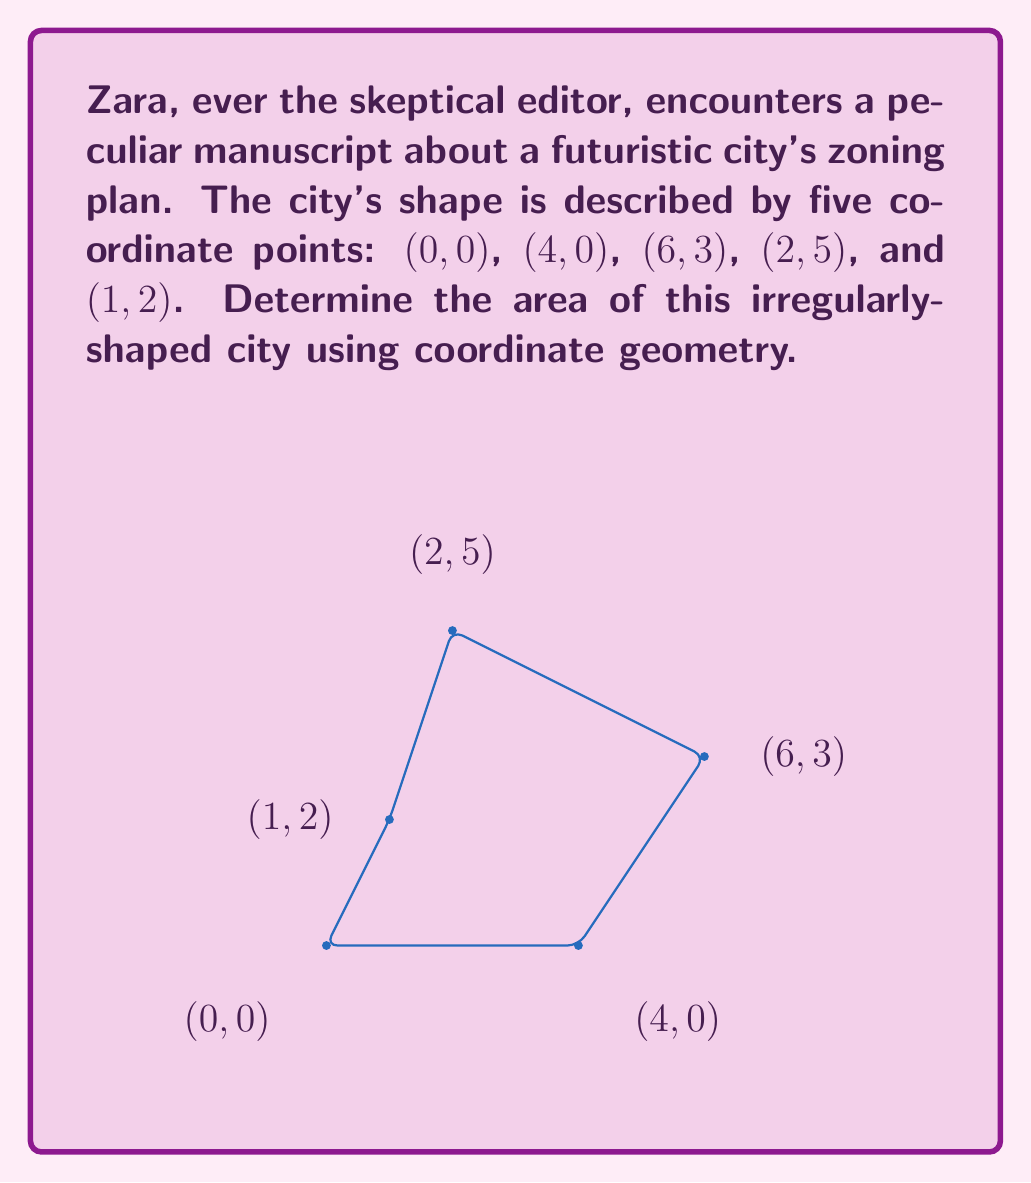Help me with this question. To find the area of this irregular polygon, we'll use the Shoelace formula (also known as the surveyor's formula). The steps are as follows:

1) List the coordinates in order (clockwise or counterclockwise), repeating the first coordinate at the end:
   $$(x_1, y_1), (x_2, y_2), (x_3, y_3), (x_4, y_4), (x_5, y_5), (x_1, y_1)$$
   In this case: (0,0), (4,0), (6,3), (2,5), (1,2), (0,0)

2) Apply the Shoelace formula:
   $$Area = \frac{1}{2}|(x_1y_2 + x_2y_3 + x_3y_4 + x_4y_5 + x_5y_1) - (y_1x_2 + y_2x_3 + y_3x_4 + y_4x_5 + y_5x_1)|$$

3) Substitute the values:
   $$Area = \frac{1}{2}|(0\cdot0 + 4\cdot3 + 6\cdot5 + 2\cdot2 + 1\cdot0) - (0\cdot4 + 0\cdot6 + 3\cdot2 + 5\cdot1 + 2\cdot0)|$$

4) Calculate:
   $$Area = \frac{1}{2}|(0 + 12 + 30 + 4 + 0) - (0 + 0 + 6 + 5 + 0)|$$
   $$Area = \frac{1}{2}|46 - 11|$$
   $$Area = \frac{1}{2} \cdot 35$$
   $$Area = 17.5$$

Thus, the area of the irregular polygon (the futuristic city) is 17.5 square units.
Answer: 17.5 square units 